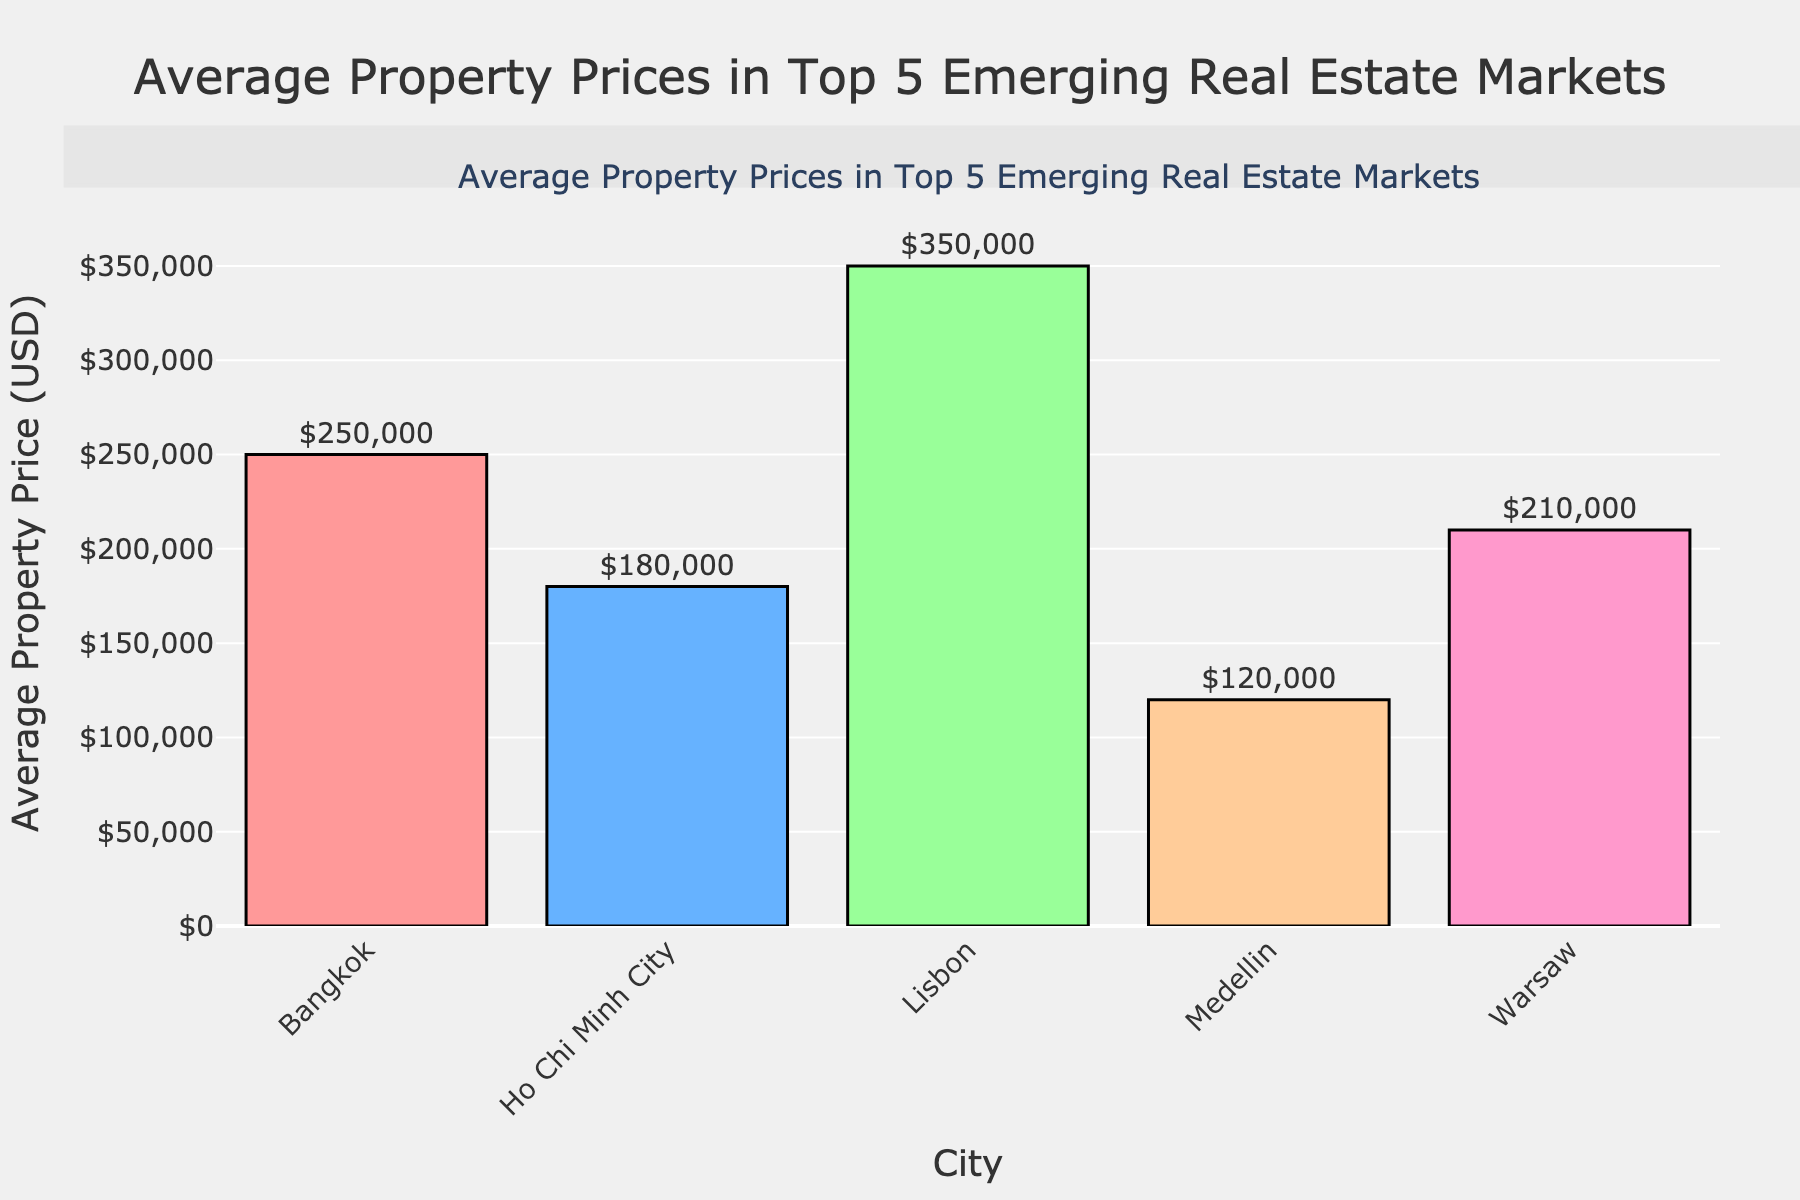What is the city with the highest average property price? The bar with the highest value is for Lisbon, which visually stands out as the tallest bar in the chart.
Answer: Lisbon Which city has the lowest average property price and how much is it? The bar corresponding to Medellin is the shortest, indicating it has the lowest average property price at $120,000.
Answer: Medellin, $120,000 How much higher is the average property price in Lisbon compared to Medellin? Lisbon has an average property price of $350,000 and Medellin has $120,000. The difference is $350,000 - $120,000 = $230,000.
Answer: $230,000 What is the average property price difference between Bangkok and Warsaw? Bangkok's average property price is $250,000, and Warsaw's is $210,000. The difference is $250,000 - $210,000 = $40,000.
Answer: $40,000 Which city has a higher average property price, Ho Chi Minh City or Warsaw? Ho Chi Minh City has an average property price of $180,000, while Warsaw's is $210,000. Warsaw has a higher price.
Answer: Warsaw What is the combined average property price of Bangkok and Ho Chi Minh City? Bangkok's average property price is $250,000 and Ho Chi Minh City's is $180,000. The combined price is $250,000 + $180,000 = $430,000.
Answer: $430,000 If a property in Lisbon is $100,000 more than the average, what would its price be? The average property price in Lisbon is $350,000. Adding $100,000 to this amount gives $350,000 + $100,000 = $450,000.
Answer: $450,000 Among all the cities shown, which one has the second highest average property price? The bar for Bangkok at $250,000 is the second tallest after Lisbon at $350,000. Thus, Bangkok has the second highest average property price.
Answer: Bangkok In which city is the average property price closest to $200,000? The average property price in Warsaw is $210,000, which is the closest to $200,000 among the listed values.
Answer: Warsaw 